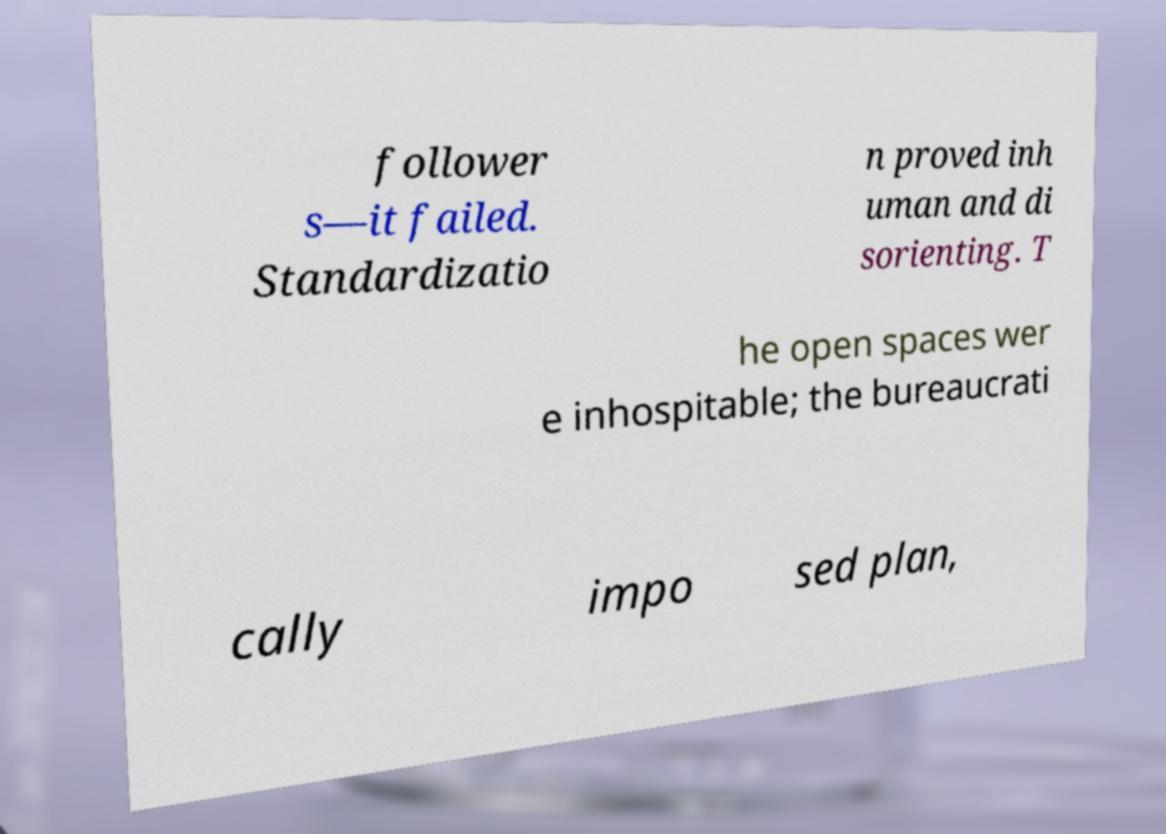Could you extract and type out the text from this image? follower s—it failed. Standardizatio n proved inh uman and di sorienting. T he open spaces wer e inhospitable; the bureaucrati cally impo sed plan, 